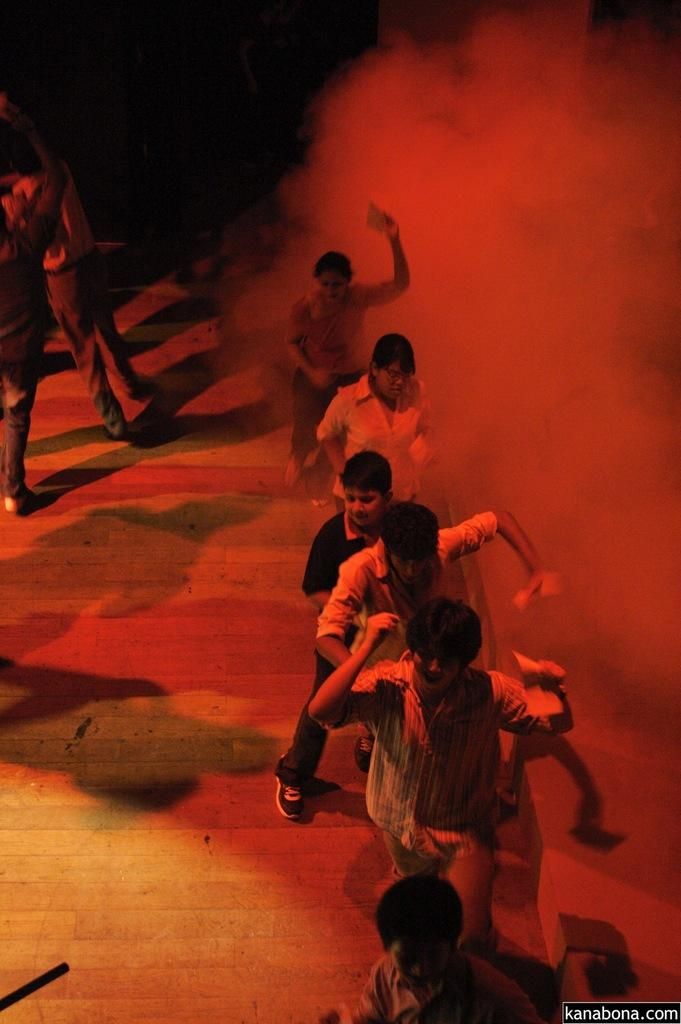Who or what is present in the image? There are people in the image. What can be seen in the image besides the people? There is smoke visible in the image. How would you describe the background of the image? The background of the image is dark. Where is the text located in the image? The text is in the bottom right side of the image. What type of comb is being used to transport people through the wilderness in the image? There is no comb or transportation depicted in the image; it features people and smoke with a dark background and text in the bottom right corner. 